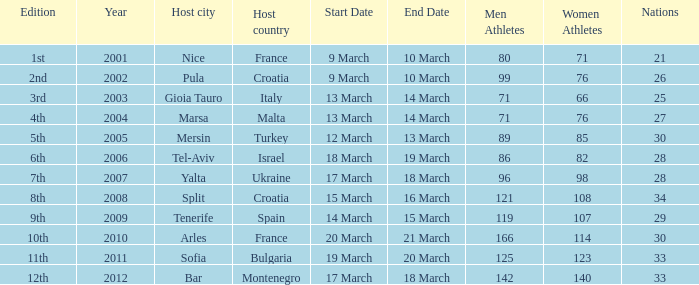What was the number of athletes for the 7th edition? 96 men/ 98 women. 